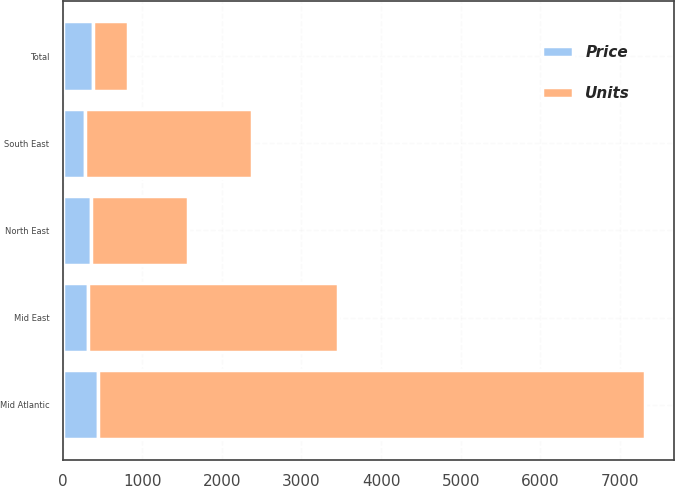<chart> <loc_0><loc_0><loc_500><loc_500><stacked_bar_chart><ecel><fcel>Mid Atlantic<fcel>North East<fcel>Mid East<fcel>South East<fcel>Total<nl><fcel>Units<fcel>6879<fcel>1221<fcel>3137<fcel>2089<fcel>439.2<nl><fcel>Price<fcel>439.2<fcel>353.9<fcel>323.5<fcel>284.9<fcel>379.9<nl></chart> 